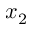Convert formula to latex. <formula><loc_0><loc_0><loc_500><loc_500>x _ { 2 }</formula> 